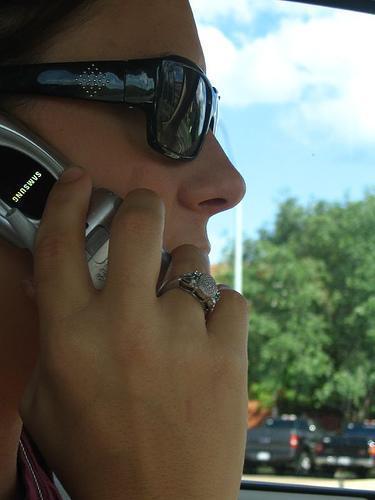How many trucks are visible?
Give a very brief answer. 2. How many birds are standing in the pizza box?
Give a very brief answer. 0. 